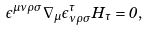<formula> <loc_0><loc_0><loc_500><loc_500>\epsilon ^ { \mu \nu \rho \sigma } \nabla _ { \mu } \epsilon _ { \nu \rho \sigma } ^ { \tau } H _ { \tau } = 0 ,</formula> 